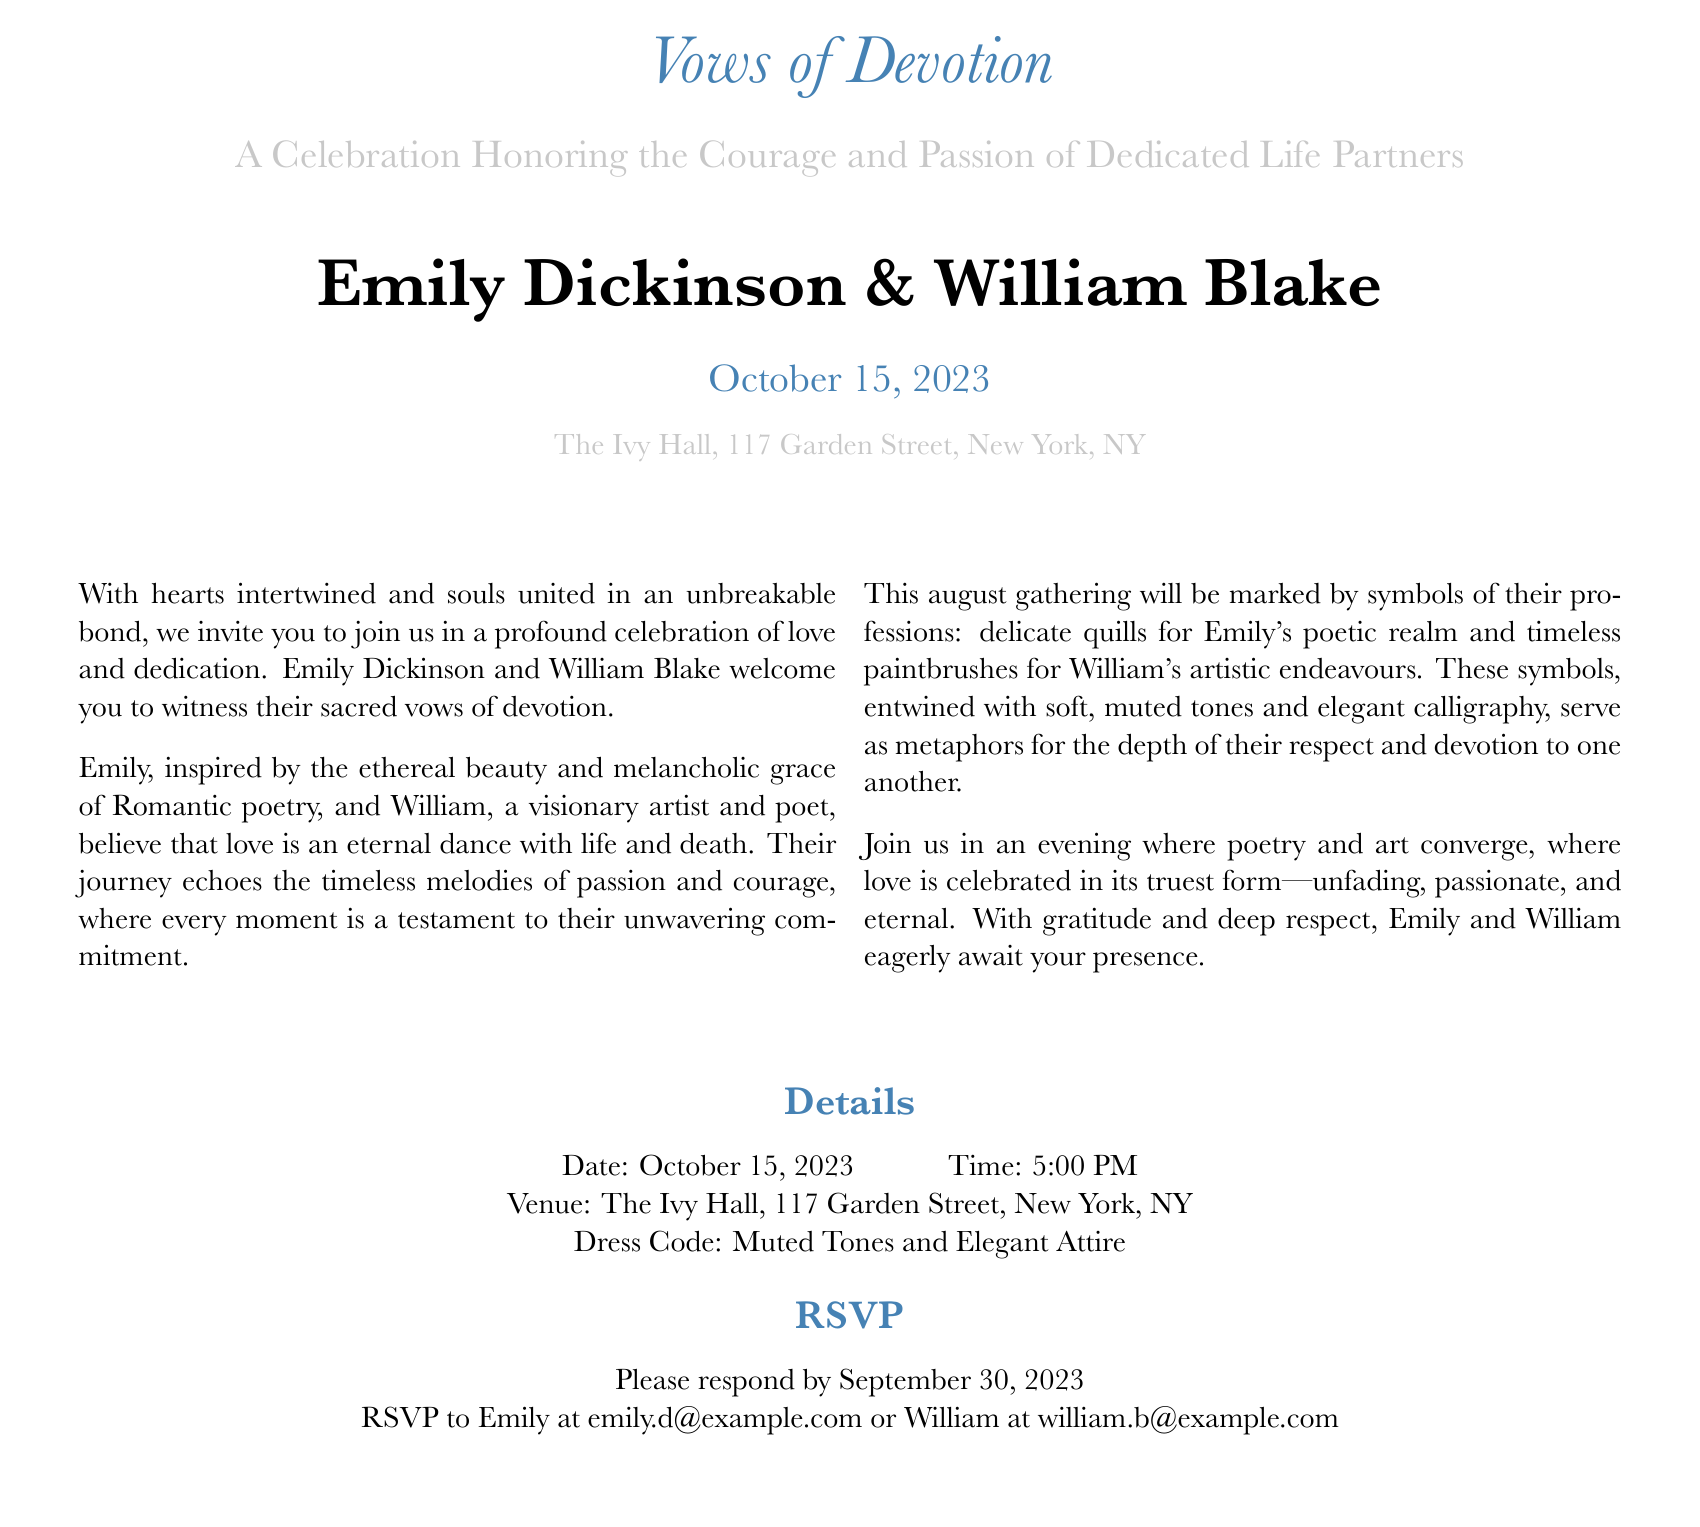What are the names of the couple? The names of the couple are presented prominently at the center of the document.
Answer: Emily Dickinson & William Blake What is the date of the celebration? The date is specified clearly in the invitation, making it easy to find.
Answer: October 15, 2023 Where is the venue located? The venue address is mentioned in the details section of the invitation.
Answer: The Ivy Hall, 117 Garden Street, New York, NY What time does the celebration start? The starting time is included in the details section, revealing when the event begins.
Answer: 5:00 PM What is the dress code for the event? The dress code is stated in the details section, guiding guests on appropriate attire.
Answer: Muted Tones and Elegant Attire Why are quills and paintbrushes used as symbols? Quills and paintbrushes represent the professions of the couple, highlighting their passions.
Answer: Their professions What type of celebration is this? The invitation describes the nature of the event, focusing on the couple's commitment.
Answer: A Celebration Honoring the Courage and Passion of Dedicated Life Partners When is the RSVP deadline? The RSVP deadline is clearly mentioned in the invitation, indicating when responses are due.
Answer: September 30, 2023 Who can guests RSVP to? The invitation specifies whom to contact for RSVPs, providing clear guidance.
Answer: Emily and William 